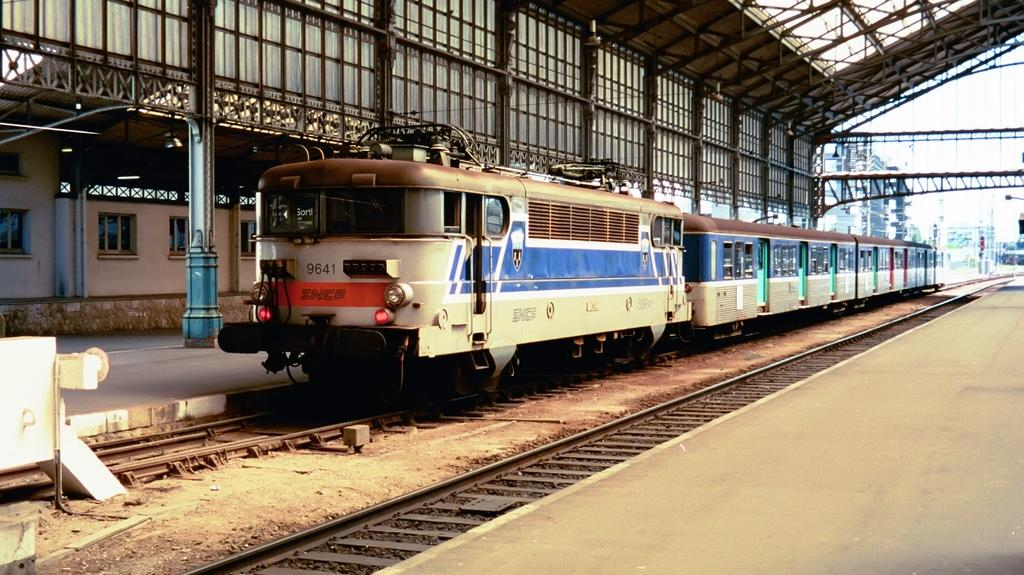What is the main subject of the image? The main subject of the image is a train. What can be seen in the middle of the image? There are two railway tracks in the middle of the image. What is located on the left side of the image? There is a platform on the left side of the image. What is visible in the background of the image? There are buildings and the sky in the background of the image. What type of mask is being worn by the train in the image? There is no mask present in the image, as it features a train on railway tracks with a platform and background elements. What type of war is being depicted in the image? There is no war depicted in the image; it features a train on railway tracks with a platform and background elements. 